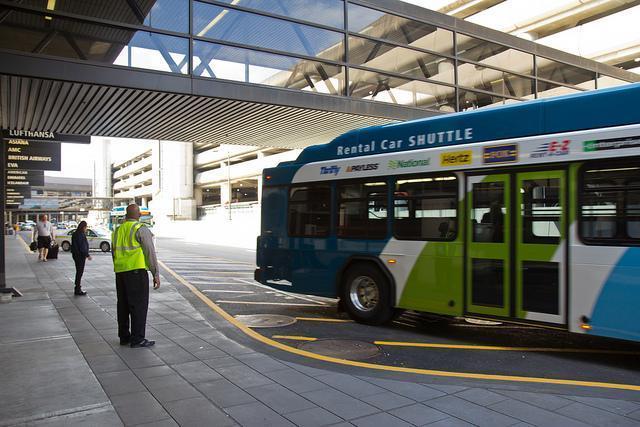How many dogs are in this picture?
Give a very brief answer. 0. 